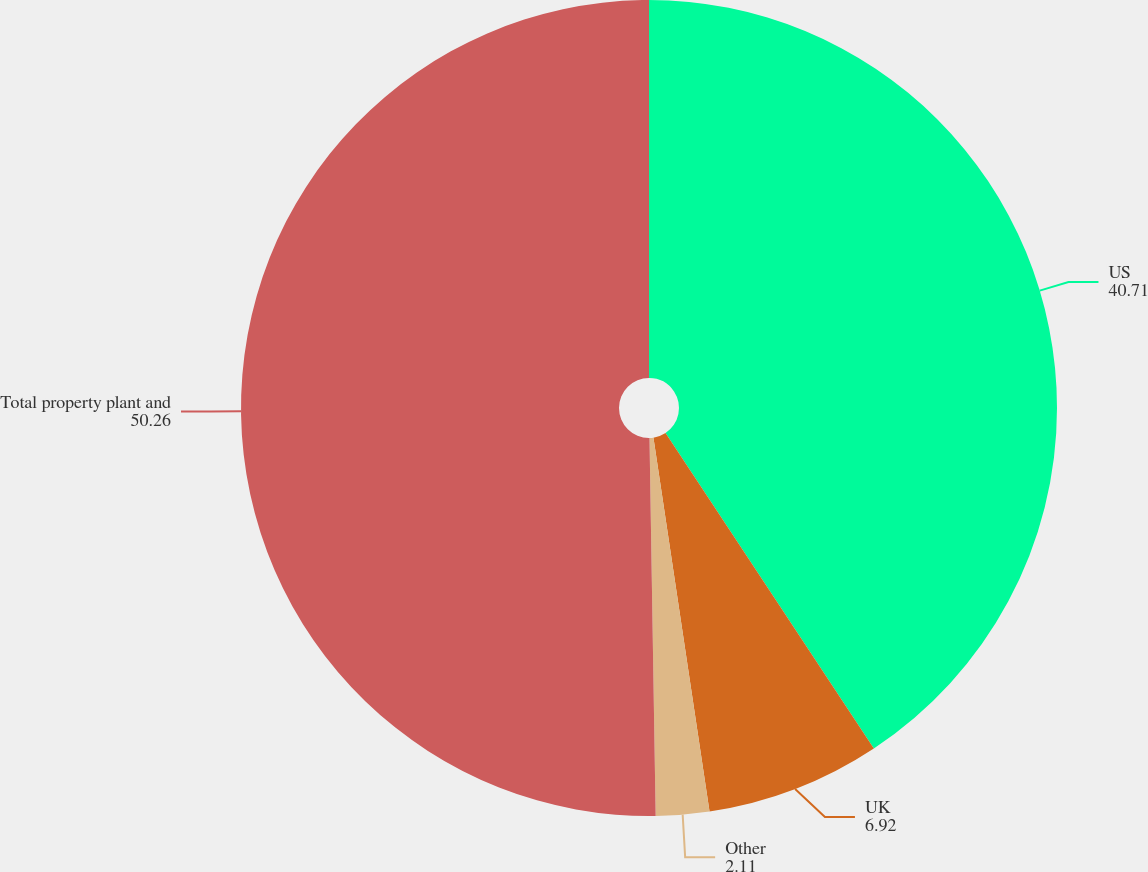Convert chart to OTSL. <chart><loc_0><loc_0><loc_500><loc_500><pie_chart><fcel>US<fcel>UK<fcel>Other<fcel>Total property plant and<nl><fcel>40.71%<fcel>6.92%<fcel>2.11%<fcel>50.26%<nl></chart> 